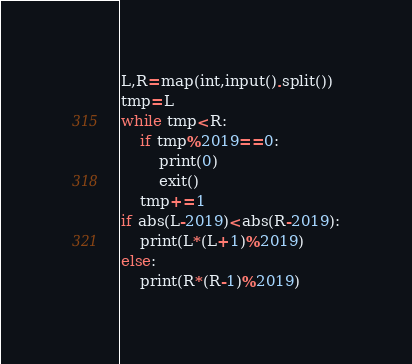Convert code to text. <code><loc_0><loc_0><loc_500><loc_500><_Python_>L,R=map(int,input().split())
tmp=L
while tmp<R:
	if tmp%2019==0:
		print(0)
		exit()
	tmp+=1
if abs(L-2019)<abs(R-2019):
	print(L*(L+1)%2019)
else:
	print(R*(R-1)%2019)</code> 